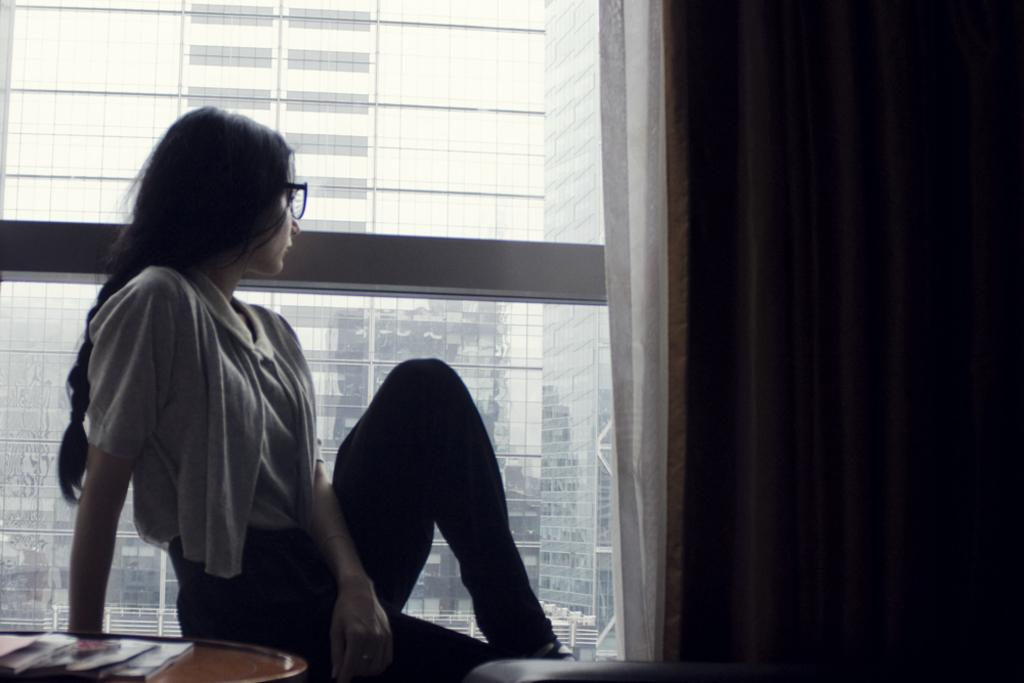What is the woman doing in the image? The woman is sitting in the image. What can be seen on the table in the image? There are objects on the table in the image. What is visible in the background of the image? There is a window in the background of the image. What can be seen through the window in the image? A building is visible through the window in the image. What reward does the woman receive for her morning troubles in the image? There is no indication in the image that the woman is receiving a reward or experiencing any troubles, so it cannot be determined from the picture. 